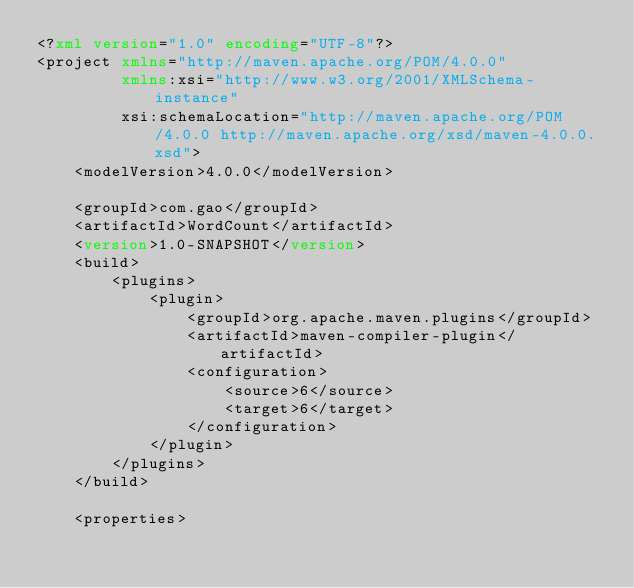Convert code to text. <code><loc_0><loc_0><loc_500><loc_500><_XML_><?xml version="1.0" encoding="UTF-8"?>
<project xmlns="http://maven.apache.org/POM/4.0.0"
         xmlns:xsi="http://www.w3.org/2001/XMLSchema-instance"
         xsi:schemaLocation="http://maven.apache.org/POM/4.0.0 http://maven.apache.org/xsd/maven-4.0.0.xsd">
    <modelVersion>4.0.0</modelVersion>

    <groupId>com.gao</groupId>
    <artifactId>WordCount</artifactId>
    <version>1.0-SNAPSHOT</version>
    <build>
        <plugins>
            <plugin>
                <groupId>org.apache.maven.plugins</groupId>
                <artifactId>maven-compiler-plugin</artifactId>
                <configuration>
                    <source>6</source>
                    <target>6</target>
                </configuration>
            </plugin>
        </plugins>
    </build>

    <properties></code> 